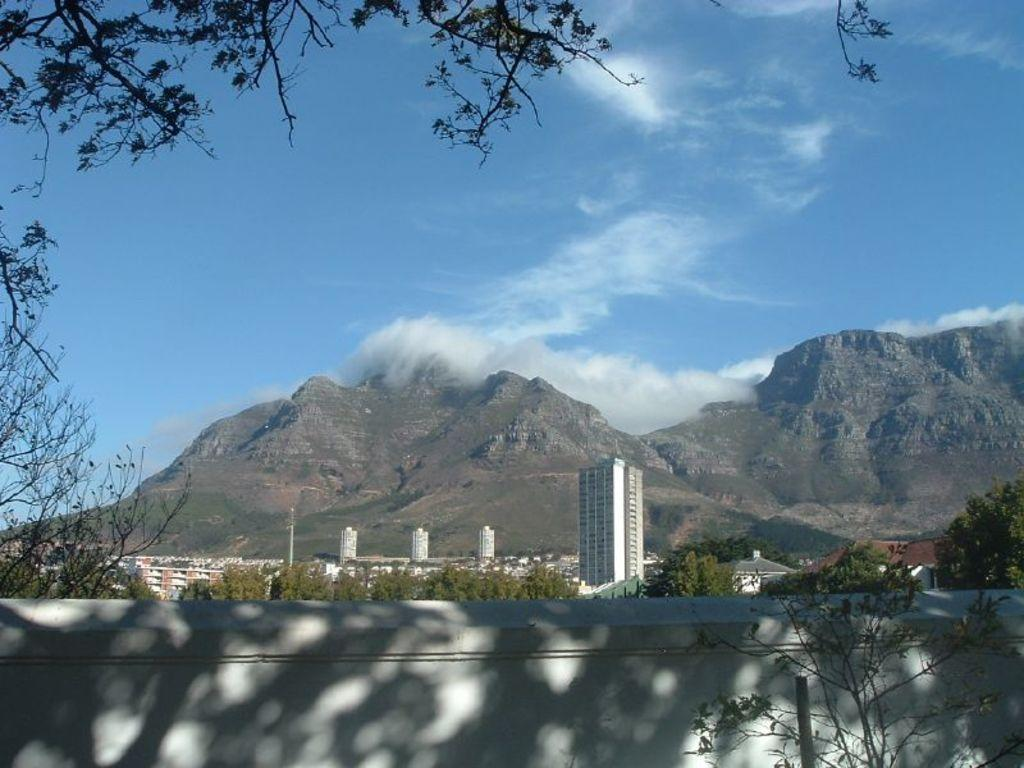What type of natural elements can be seen in the image? There are trees in the image. What type of man-made structures are present in the image? There are buildings in the image. What type of geographical feature is visible in the image? There are mountains in the image. What is visible in the sky in the image? There are clouds visible in the sky in the image. What invention is being showcased in the image? There is no invention being showcased in the image; it features trees, buildings, mountains, and clouds. What team is playing in the hall depicted in the image? There is no hall or team present in the image. 